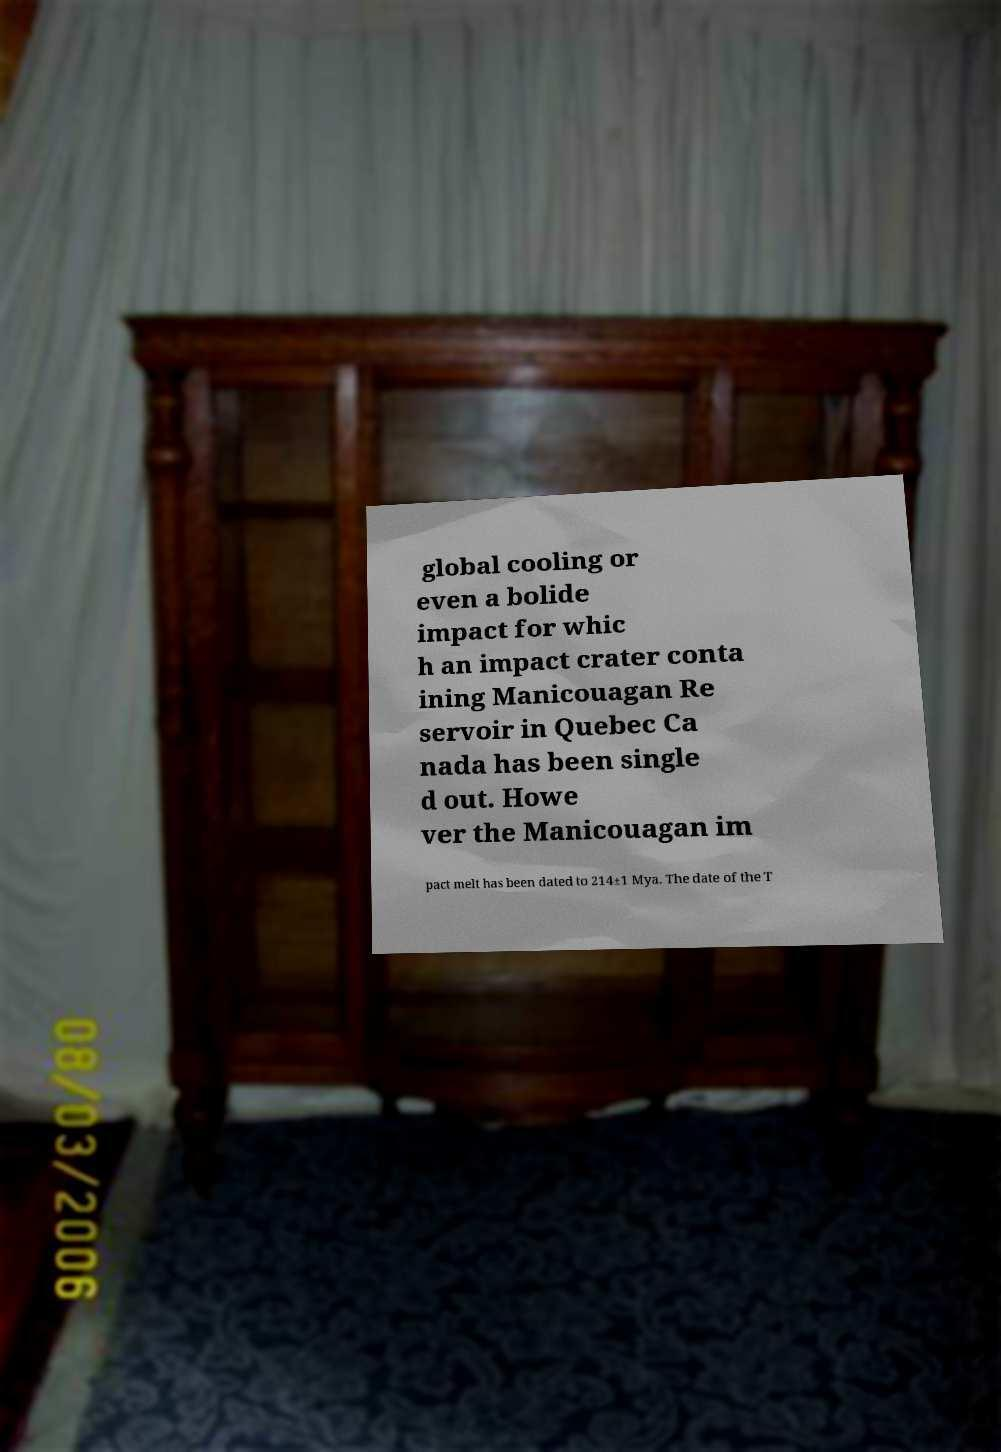Could you assist in decoding the text presented in this image and type it out clearly? global cooling or even a bolide impact for whic h an impact crater conta ining Manicouagan Re servoir in Quebec Ca nada has been single d out. Howe ver the Manicouagan im pact melt has been dated to 214±1 Mya. The date of the T 